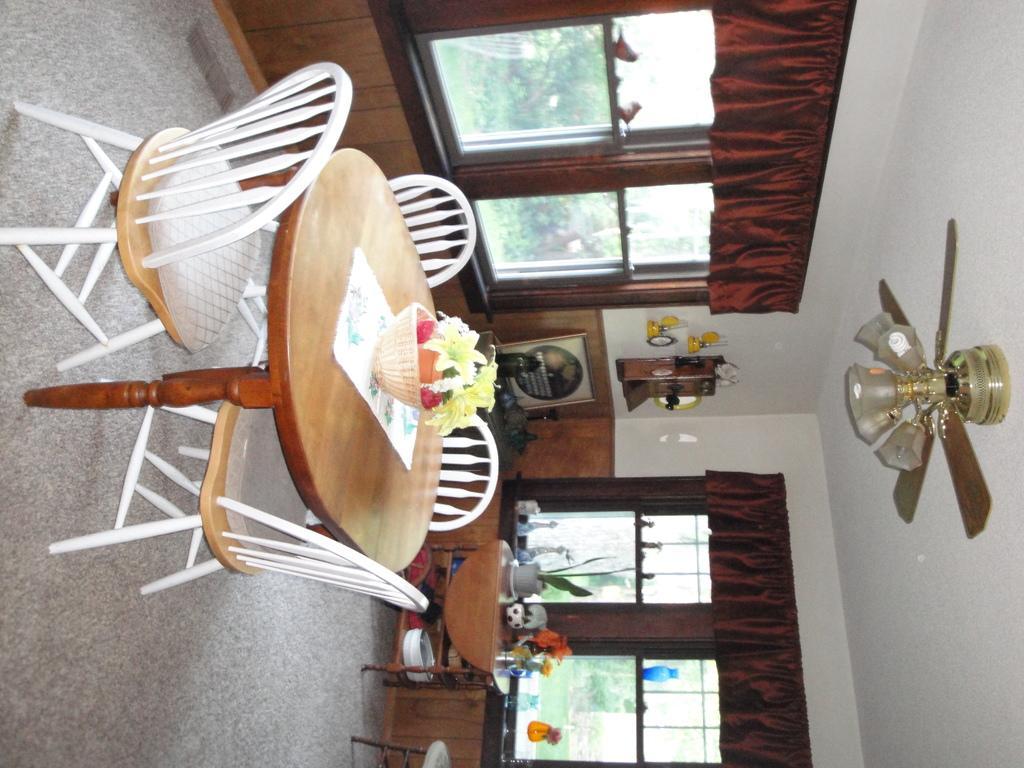Describe this image in one or two sentences. In this image we can see the interior of the house. There is a fan in the image. There are many objects placed on the tables. There are many objects on the wall. There are many trees and plants in the image. There is a grassy land in the image. There are many chairs in the image. There are windows in the image. 